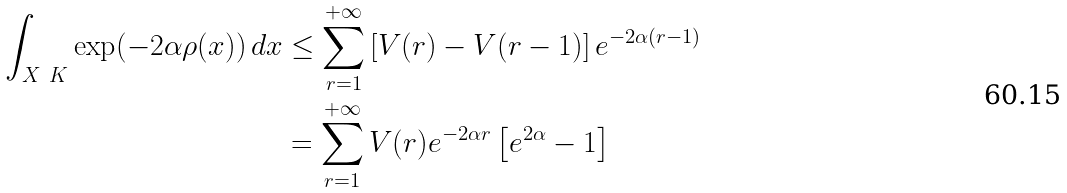Convert formula to latex. <formula><loc_0><loc_0><loc_500><loc_500>\int _ { X \ K } \exp ( - 2 \alpha \rho ( x ) ) \, d x & \leq \sum _ { r = 1 } ^ { + \infty } \left [ V ( r ) - V ( r - 1 ) \right ] e ^ { - 2 \alpha ( r - 1 ) } \\ & = \sum _ { r = 1 } ^ { + \infty } V ( r ) e ^ { - 2 \alpha r } \left [ e ^ { 2 \alpha } - 1 \right ]</formula> 